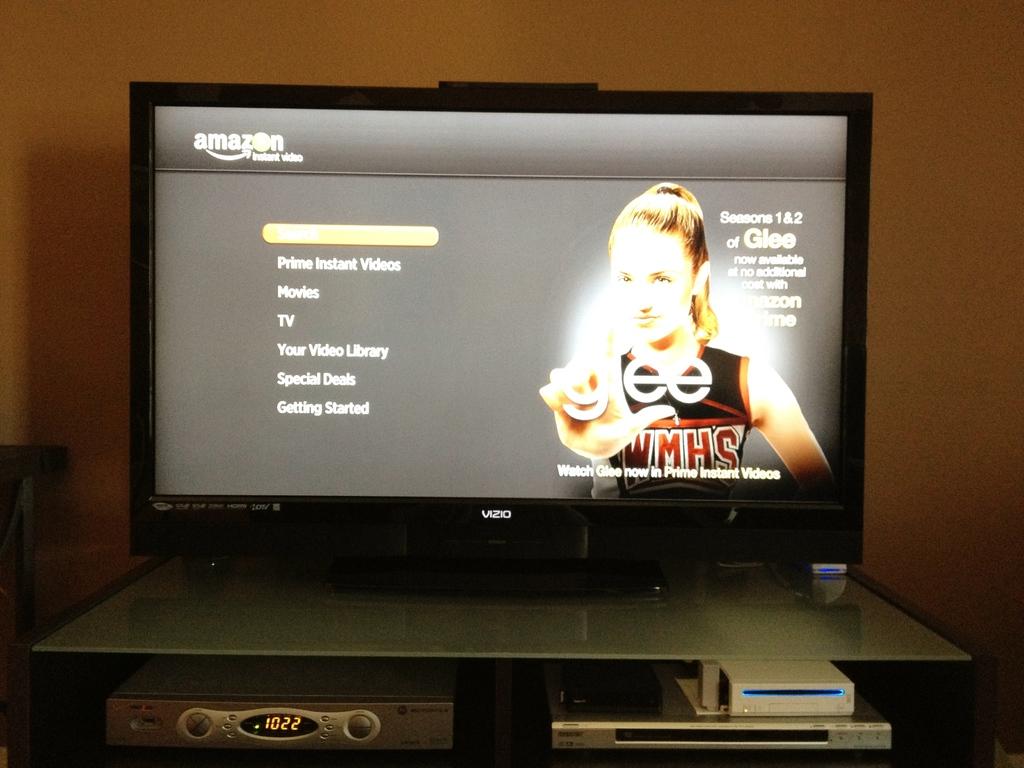What show is on the screen?
Offer a terse response. Glee. Which seasons are available?
Ensure brevity in your answer.  1 & 2. 